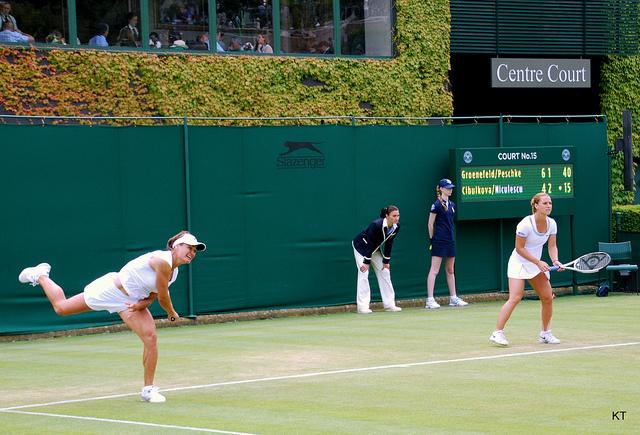Where is Center Court?
Quick response, please. Behind them. What is blue object on ground?
Answer briefly. Bag. Is the line judge a male or female?
Answer briefly. Female. Does she have a playing partner?
Be succinct. Yes. Have you ever been to a tennis match?
Answer briefly. No. 